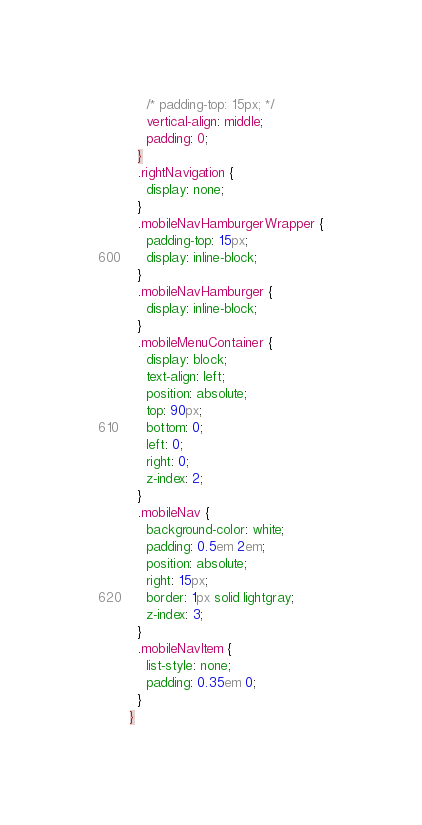<code> <loc_0><loc_0><loc_500><loc_500><_CSS_>    /* padding-top: 15px; */
    vertical-align: middle;
    padding: 0;
  }
  .rightNavigation {
    display: none;
  }
  .mobileNavHamburgerWrapper {
    padding-top: 15px;
    display: inline-block;
  }
  .mobileNavHamburger {
    display: inline-block;
  }
  .mobileMenuContainer {
    display: block;
    text-align: left;
    position: absolute;
    top: 90px;
    bottom: 0;
    left: 0;
    right: 0;
    z-index: 2;
  }
  .mobileNav {
    background-color: white;
    padding: 0.5em 2em;
    position: absolute;
    right: 15px;
    border: 1px solid lightgray;
    z-index: 3;
  }
  .mobileNavItem {
    list-style: none;
    padding: 0.35em 0;
  }
}
</code> 